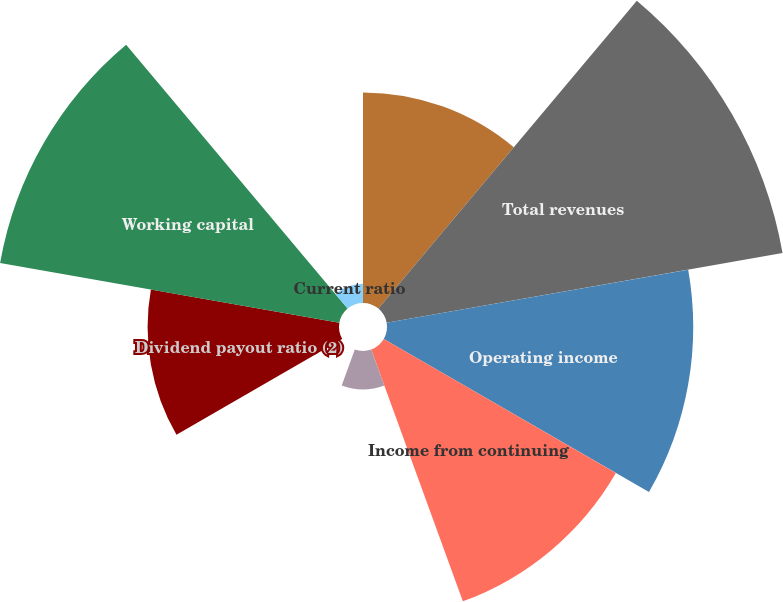<chart> <loc_0><loc_0><loc_500><loc_500><pie_chart><fcel>(Dollars and shares in<fcel>Total revenues<fcel>Operating income<fcel>Income from continuing<fcel>Earnings per common share from<fcel>Dividends per share<fcel>Dividend payout ratio (2)<fcel>Working capital<fcel>Current ratio<nl><fcel>11.83%<fcel>22.58%<fcel>17.2%<fcel>15.05%<fcel>2.15%<fcel>0.0%<fcel>10.75%<fcel>19.35%<fcel>1.08%<nl></chart> 